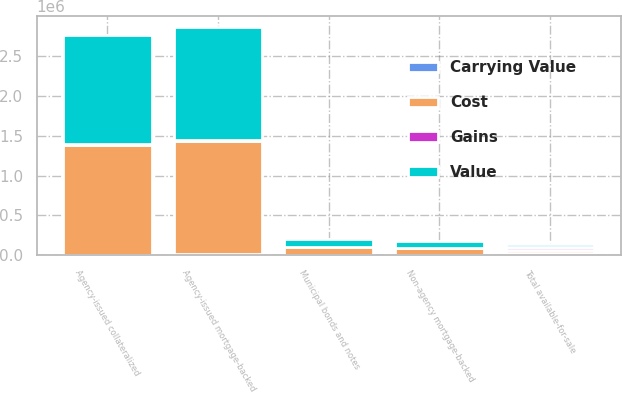Convert chart to OTSL. <chart><loc_0><loc_0><loc_500><loc_500><stacked_bar_chart><ecel><fcel>Agency-issued mortgage-backed<fcel>Agency-issued collateralized<fcel>Non-agency mortgage-backed<fcel>Municipal bonds and notes<fcel>Total available-for-sale<nl><fcel>Value<fcel>1.41382e+06<fcel>1.36079e+06<fcel>89155<fcel>100504<fcel>34460<nl><fcel>Gains<fcel>14050<fcel>17142<fcel>48<fcel>2429<fcel>40008<nl><fcel>Carrying Value<fcel>17237<fcel>5557<fcel>5507<fcel>56<fcel>28912<nl><fcel>Cost<fcel>1.41063e+06<fcel>1.37238e+06<fcel>83696<fcel>102877<fcel>34460<nl></chart> 